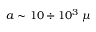Convert formula to latex. <formula><loc_0><loc_0><loc_500><loc_500>a \sim 1 0 \div 1 0 ^ { 3 } \, \mu</formula> 